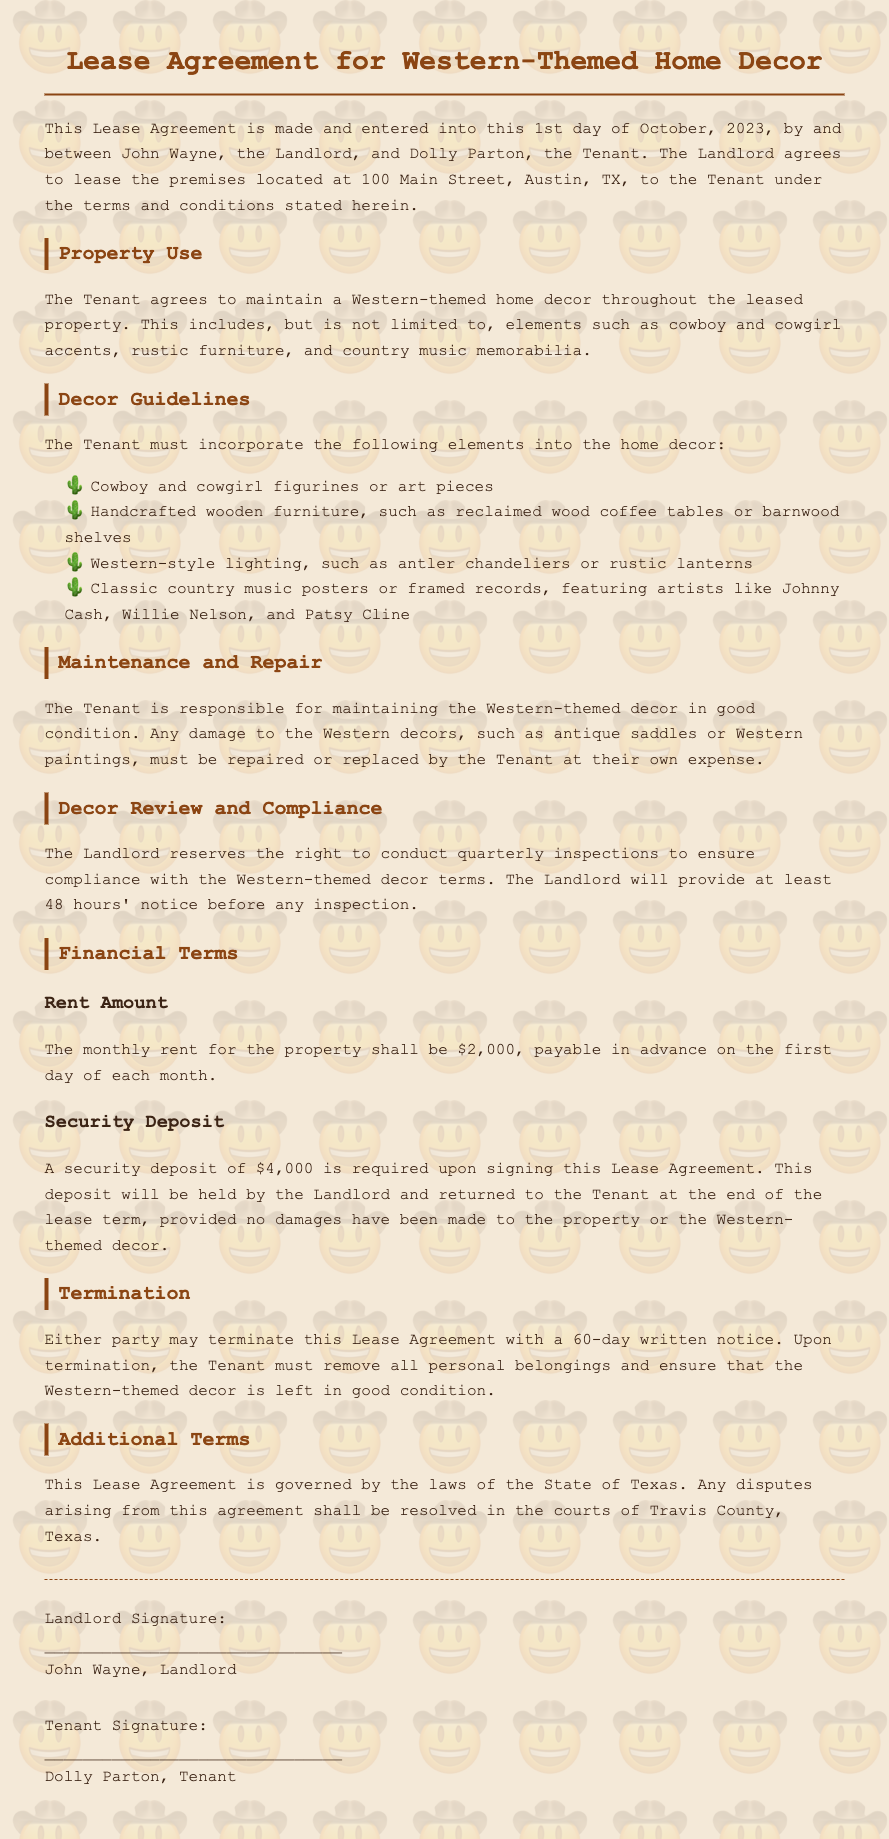What is the name of the landlord? The landlord's name is stated in the document, which introduces John Wayne as the landlord.
Answer: John Wayne What is the monthly rent amount? The document specifies the monthly rent for the property in the Financial Terms section.
Answer: $2,000 What is required as a security deposit? The security deposit amount is mentioned under Financial Terms, outlining what is needed when signing the lease agreement.
Answer: $4,000 What type of decor must be maintained? The document states that the Tenant must maintain a specific theme throughout the property, which is repeated in several sections.
Answer: Western-themed home decor How many days notice is required for termination? The termination section specifies the amount of notice required from either party to terminate the lease.
Answer: 60 days What does the Landlord reserve the right to do quarterly? The document indicates a specific action that the Landlord can take to ensure the terms of the lease are being followed.
Answer: Conduct inspections What is one required decor element? The decor guidelines list several specific items that must be maintained, and selecting one of these would answer the question effectively.
Answer: Cowboy and cowgirl figurines What will happen to the security deposit at the end of the lease? The document clarifies the conditions under which the security deposit will be returned to the Tenant after the lease period.
Answer: Returned In which county are disputes to be resolved? The document points out the geographic location relevant to legal matters arising from the agreement, specified in additional terms.
Answer: Travis County Who is the tenant? The document introduces the parties involved, indicating the Tenant's identity clearly.
Answer: Dolly Parton 